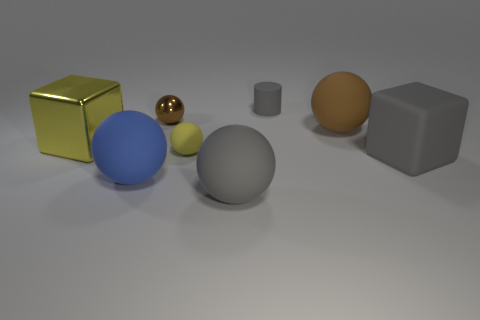Subtract all purple cylinders. How many brown balls are left? 2 Subtract all brown metallic balls. How many balls are left? 4 Subtract 3 balls. How many balls are left? 2 Subtract all gray spheres. How many spheres are left? 4 Add 1 small gray objects. How many objects exist? 9 Subtract all spheres. How many objects are left? 3 Subtract all green balls. Subtract all red blocks. How many balls are left? 5 Subtract 0 red cubes. How many objects are left? 8 Subtract all tiny yellow rubber cylinders. Subtract all large blue matte things. How many objects are left? 7 Add 6 cylinders. How many cylinders are left? 7 